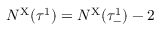Convert formula to latex. <formula><loc_0><loc_0><loc_500><loc_500>N ^ { X } ( \tau ^ { 1 } ) = N ^ { X } ( \tau _ { - } ^ { 1 } ) - 2</formula> 